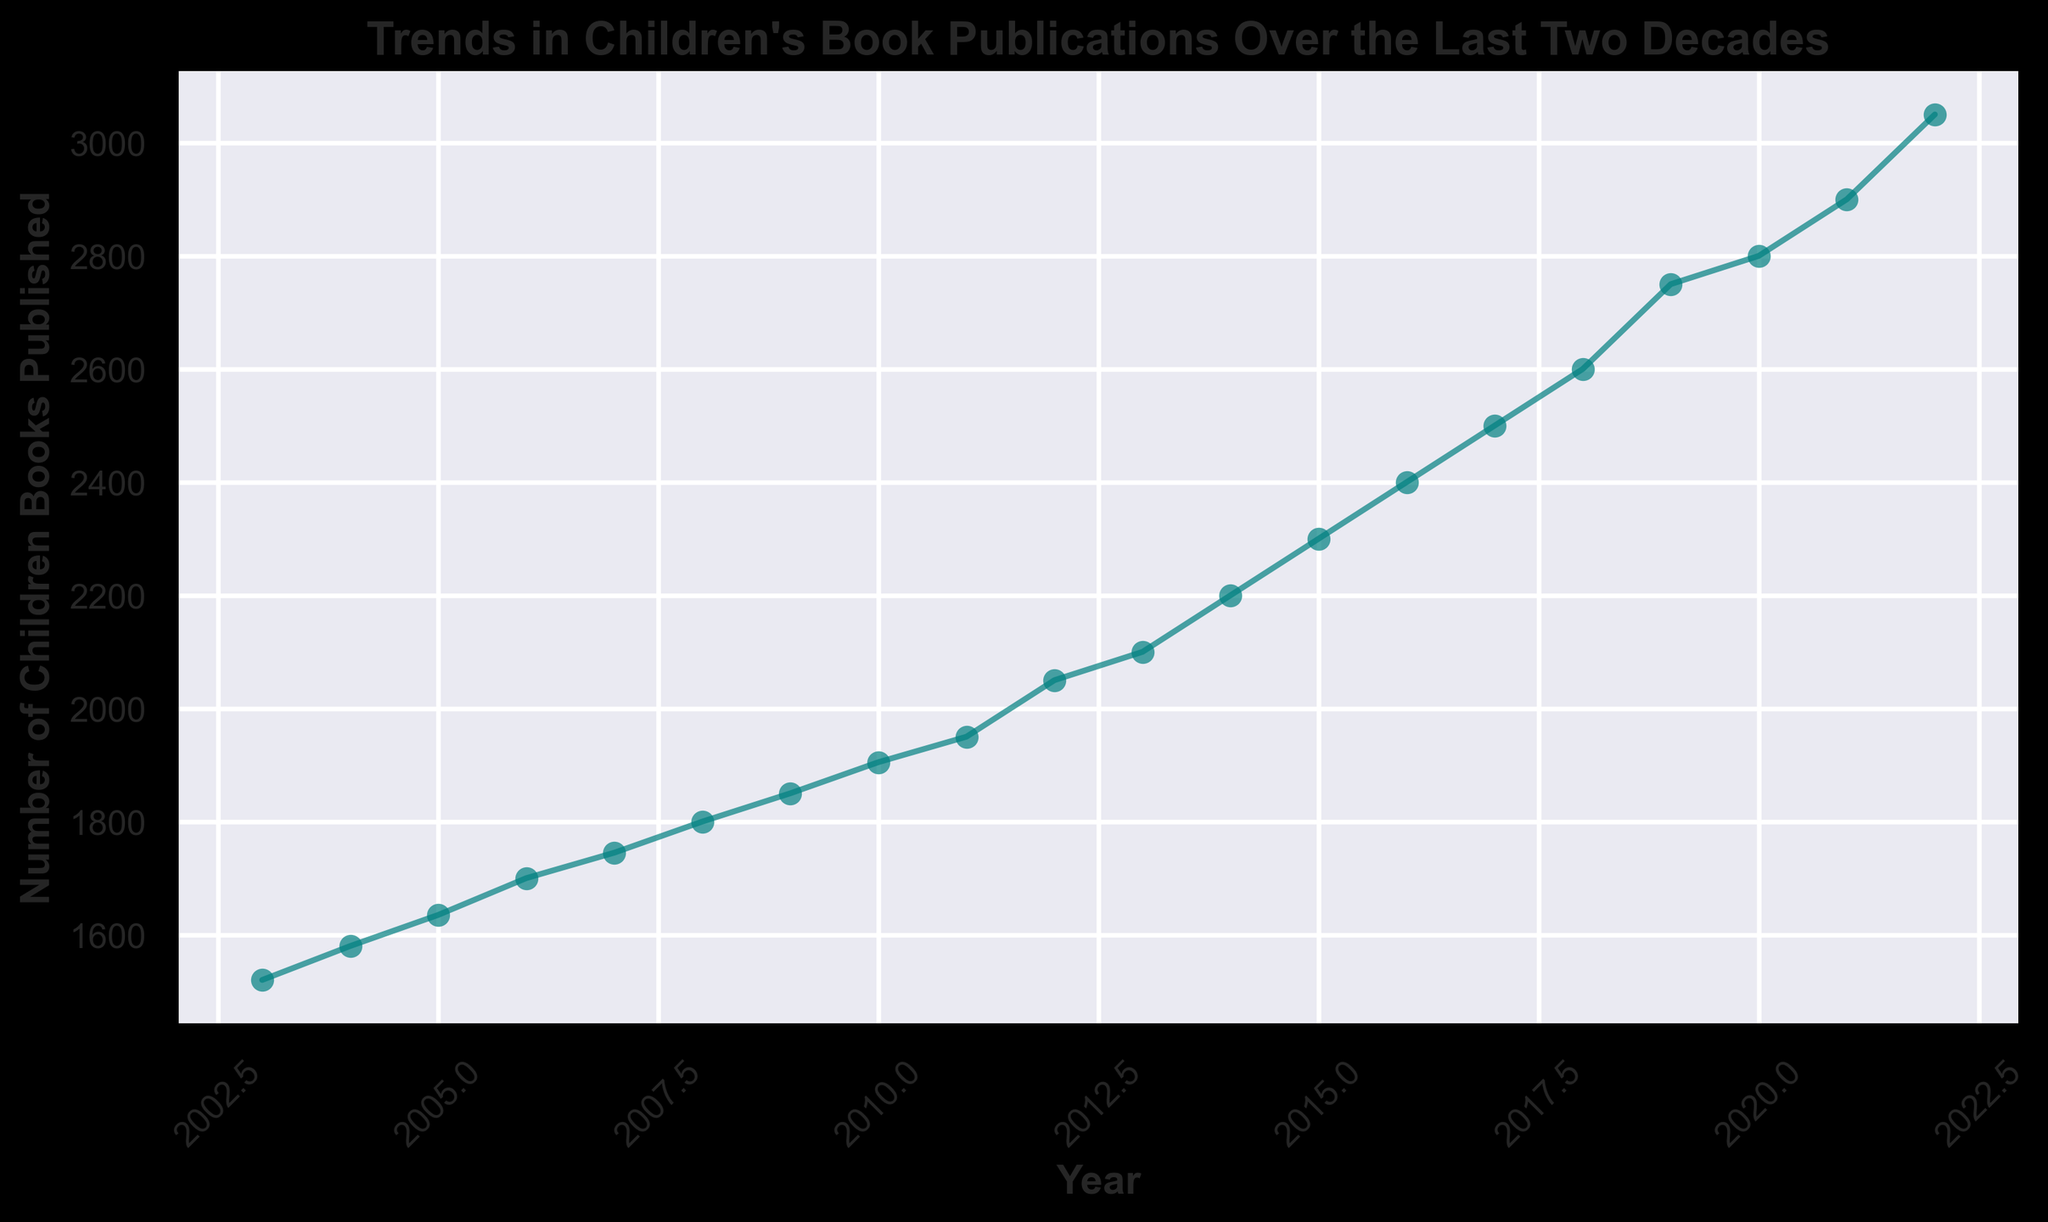How has the number of children's books published changed from 2003 to 2022? From 2003 to 2022, the number of children's books published has steadily increased every year. For example, it started at 1520 in 2003 and rose to 3050 in 2022, indicating a positive growth trend.
Answer: Increased Which year had the highest number of children's books published? By examining the last data point on the figure, we see that 2022 had the highest number of children's books published, which is 3050.
Answer: 2022 Compare the number of children's books published in 2010 and 2020. By locating the points for 2010 and 2020 on the figure, we see that in 2010, there were 1905 books published, while in 2020, there were 2800 books published. This shows an increase of 895 books over the decade.
Answer: 2020 had more Between which consecutive years was the largest increase in the number of children's books published? By examining the lengths of the segments between the data points year-over-year, the largest increase appears between 2019 (2750) and 2020 (2800), giving an increase of 250 books.
Answer: Between 2019 and 2020 Based on the trend from the past two decades, predict the number of children's books published in 2023. The trend shows a steady increase every year. To predict for 2023, estimate the continuing growth. From 2021 to 2022, the number increased by 150 (3050 - 2900). Applying a similar increase, we predict 3200 books for 2023.
Answer: Approximately 3200 What is the average number of children's books published per year from 2003 to 2022? Sum the number of books published from each year (1520+1580+1635+1700+1745+1800+1850+1905+1950+2050+2100+2200+2300+2400+2500+2600+2750+2800+2900+3050 = 49135). There are 20 years in total, so the average is 49135/20 = 2456.75.
Answer: 2456.75 Which decade saw the higher increase in children's book publications: 2003-2012 or 2013-2022? Calculate the increase for each decade: 2003-2012 (2050 - 1520 = 530) and 2013-2022 (3050 - 2100 = 950). The decade from 2013 to 2022 had a higher increase.
Answer: 2013-2022 Describe the visual style of the plot. The plot has a teal line with circle markers, indicating data points for each year. The line is smooth with slight alpha for the line and bold style for titles and labels. The plot background uses a seaborn dark palette style.
Answer: Teal line with circles, dark background 